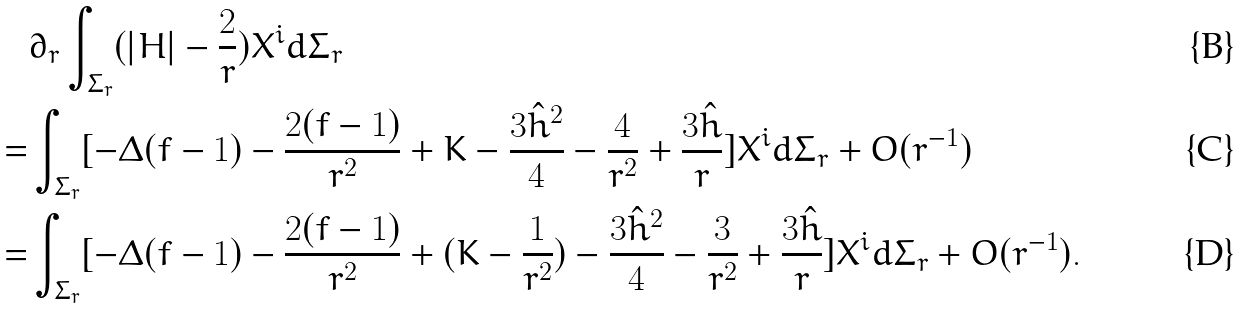Convert formula to latex. <formula><loc_0><loc_0><loc_500><loc_500>& \partial _ { r } \int _ { \Sigma _ { r } } ( | H | - \frac { 2 } { r } ) X ^ { i } d \Sigma _ { r } \\ = & \int _ { \Sigma _ { r } } [ - \Delta ( f - 1 ) - \frac { 2 ( f - 1 ) } { r ^ { 2 } } + K - \frac { 3 \hat { h } ^ { 2 } } { 4 } - \frac { 4 } { r ^ { 2 } } + \frac { 3 \hat { h } } { r } ] X ^ { i } d \Sigma _ { r } + O ( r ^ { - 1 } ) \\ = & \int _ { \Sigma _ { r } } [ - \Delta ( f - 1 ) - \frac { 2 ( f - 1 ) } { r ^ { 2 } } + ( K - \frac { 1 } { r ^ { 2 } } ) - \frac { 3 \hat { h } ^ { 2 } } { 4 } - \frac { 3 } { r ^ { 2 } } + \frac { 3 \hat { h } } { r } ] X ^ { i } d \Sigma _ { r } + O ( r ^ { - 1 } ) .</formula> 